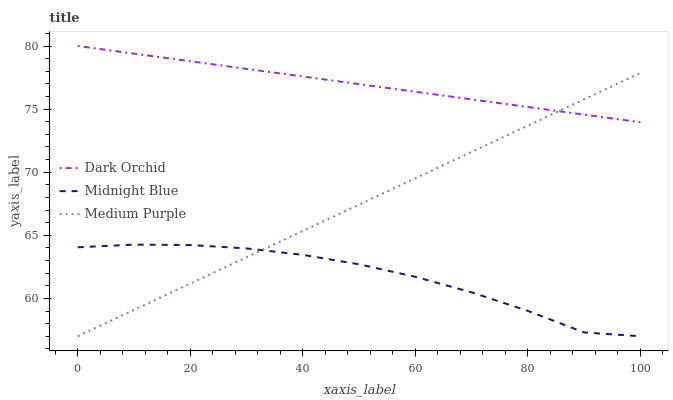Does Midnight Blue have the minimum area under the curve?
Answer yes or no. Yes. Does Dark Orchid have the maximum area under the curve?
Answer yes or no. Yes. Does Dark Orchid have the minimum area under the curve?
Answer yes or no. No. Does Midnight Blue have the maximum area under the curve?
Answer yes or no. No. Is Medium Purple the smoothest?
Answer yes or no. Yes. Is Midnight Blue the roughest?
Answer yes or no. Yes. Is Dark Orchid the smoothest?
Answer yes or no. No. Is Dark Orchid the roughest?
Answer yes or no. No. Does Medium Purple have the lowest value?
Answer yes or no. Yes. Does Dark Orchid have the lowest value?
Answer yes or no. No. Does Dark Orchid have the highest value?
Answer yes or no. Yes. Does Midnight Blue have the highest value?
Answer yes or no. No. Is Midnight Blue less than Dark Orchid?
Answer yes or no. Yes. Is Dark Orchid greater than Midnight Blue?
Answer yes or no. Yes. Does Dark Orchid intersect Medium Purple?
Answer yes or no. Yes. Is Dark Orchid less than Medium Purple?
Answer yes or no. No. Is Dark Orchid greater than Medium Purple?
Answer yes or no. No. Does Midnight Blue intersect Dark Orchid?
Answer yes or no. No. 